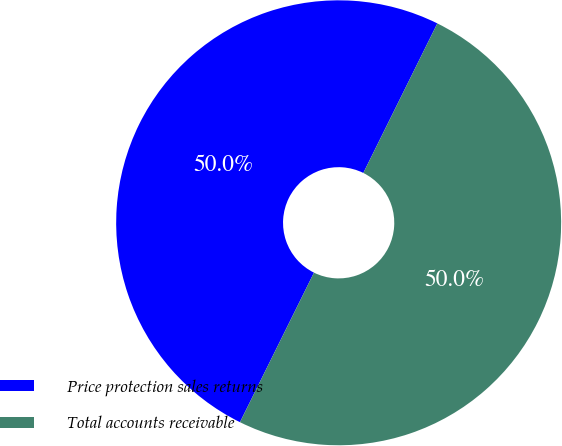<chart> <loc_0><loc_0><loc_500><loc_500><pie_chart><fcel>Price protection sales returns<fcel>Total accounts receivable<nl><fcel>50.0%<fcel>50.0%<nl></chart> 